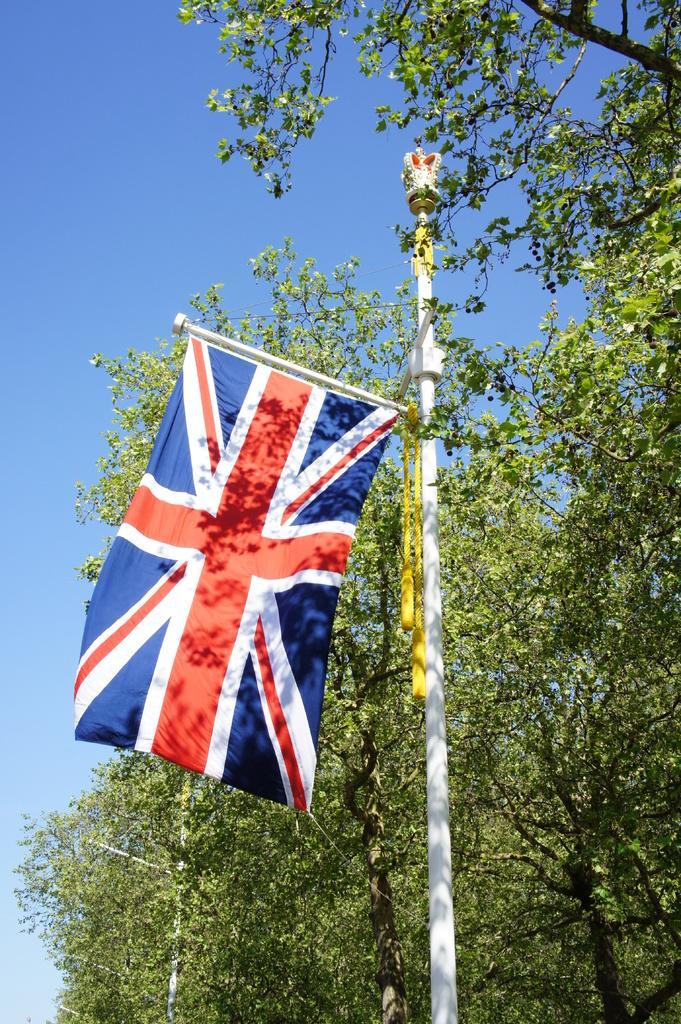How would you summarize this image in a sentence or two? In this image I can see a pole with a flag and trees on the right hand side of the image. At the top of the image I can see the sky.  